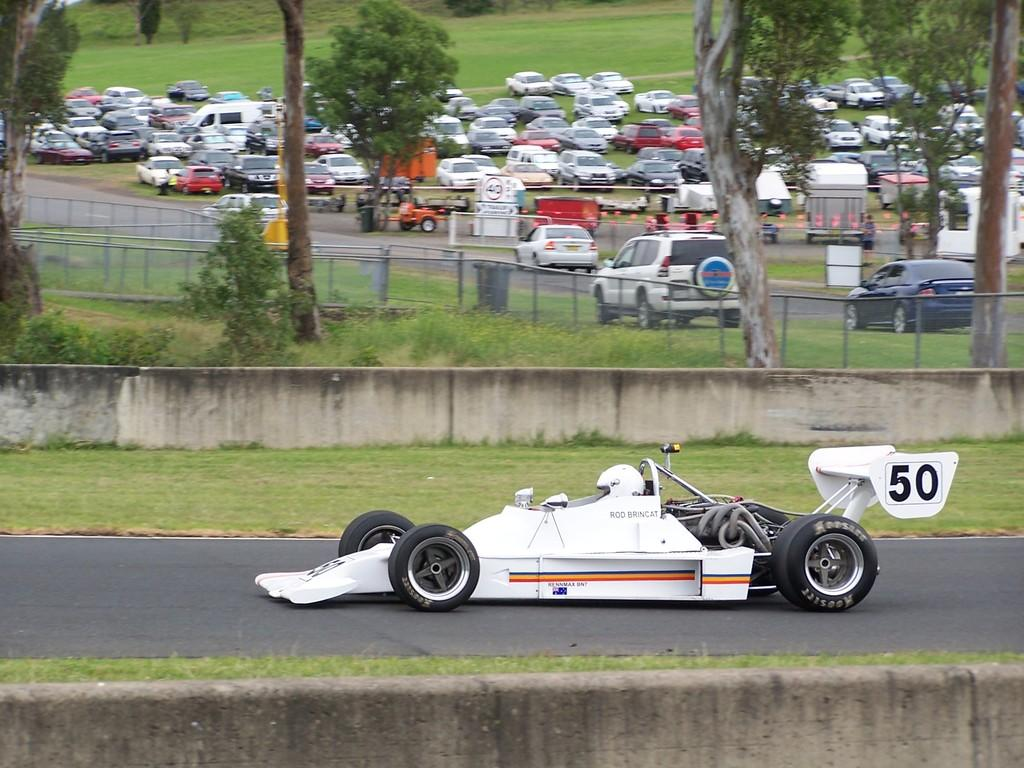What is the main subject of the image? There is a vehicle on the road in the image. What can be seen in the background of the image? There is a wall and trees visible in the background of the image. Are there any other vehicles in the image? Yes, there is a group of vehicles in the background of the image. What type of face can be seen on the vehicle in the image? There is no face visible on the vehicle in the image. What route is the vehicle taking in the image? The image does not provide information about the vehicle's route. 